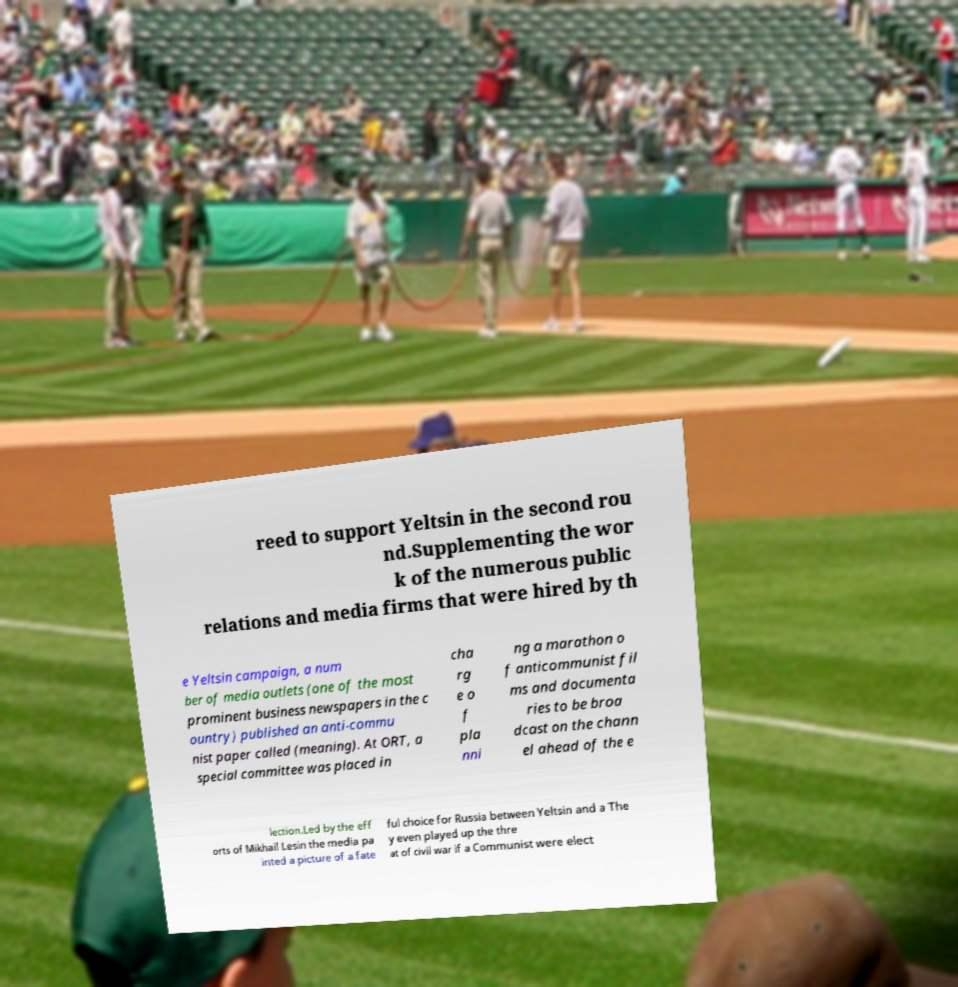I need the written content from this picture converted into text. Can you do that? reed to support Yeltsin in the second rou nd.Supplementing the wor k of the numerous public relations and media firms that were hired by th e Yeltsin campaign, a num ber of media outlets (one of the most prominent business newspapers in the c ountry) published an anti-commu nist paper called (meaning). At ORT, a special committee was placed in cha rg e o f pla nni ng a marathon o f anticommunist fil ms and documenta ries to be broa dcast on the chann el ahead of the e lection.Led by the eff orts of Mikhail Lesin the media pa inted a picture of a fate ful choice for Russia between Yeltsin and a The y even played up the thre at of civil war if a Communist were elect 